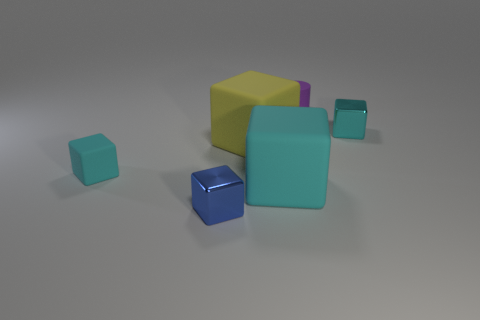What number of rubber objects are the same size as the blue cube?
Give a very brief answer. 2. There is a rubber thing that is right of the yellow rubber block and in front of the big yellow rubber object; what color is it?
Your answer should be very brief. Cyan. Is the number of blue things behind the big yellow rubber block greater than the number of cyan things?
Provide a succinct answer. No. Is there a tiny rubber sphere?
Offer a very short reply. No. Is the cylinder the same color as the tiny rubber cube?
Your answer should be compact. No. How many tiny objects are either cyan cubes or purple objects?
Make the answer very short. 3. Is there any other thing that is the same color as the small matte cube?
Ensure brevity in your answer.  Yes. What is the shape of the big yellow thing that is the same material as the large cyan cube?
Your answer should be very brief. Cube. What is the size of the cyan rubber cube to the right of the blue cube?
Give a very brief answer. Large. The yellow matte object is what shape?
Your response must be concise. Cube. 